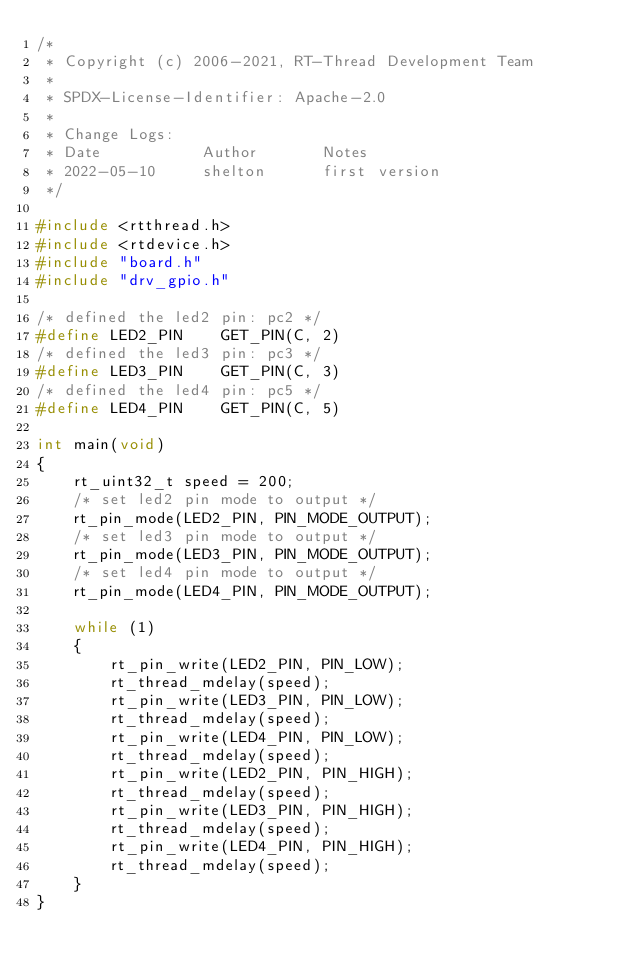<code> <loc_0><loc_0><loc_500><loc_500><_C_>/*
 * Copyright (c) 2006-2021, RT-Thread Development Team
 *
 * SPDX-License-Identifier: Apache-2.0
 *
 * Change Logs:
 * Date           Author       Notes
 * 2022-05-10     shelton      first version
 */

#include <rtthread.h>
#include <rtdevice.h>
#include "board.h"
#include "drv_gpio.h"

/* defined the led2 pin: pc2 */
#define LED2_PIN    GET_PIN(C, 2)
/* defined the led3 pin: pc3 */
#define LED3_PIN    GET_PIN(C, 3)
/* defined the led4 pin: pc5 */
#define LED4_PIN    GET_PIN(C, 5)

int main(void)
{
    rt_uint32_t speed = 200;
    /* set led2 pin mode to output */
    rt_pin_mode(LED2_PIN, PIN_MODE_OUTPUT);
    /* set led3 pin mode to output */
    rt_pin_mode(LED3_PIN, PIN_MODE_OUTPUT);
    /* set led4 pin mode to output */
    rt_pin_mode(LED4_PIN, PIN_MODE_OUTPUT);

    while (1)
    {
        rt_pin_write(LED2_PIN, PIN_LOW);
        rt_thread_mdelay(speed);
        rt_pin_write(LED3_PIN, PIN_LOW);
        rt_thread_mdelay(speed);
        rt_pin_write(LED4_PIN, PIN_LOW);
        rt_thread_mdelay(speed);
        rt_pin_write(LED2_PIN, PIN_HIGH);
        rt_thread_mdelay(speed);
        rt_pin_write(LED3_PIN, PIN_HIGH);
        rt_thread_mdelay(speed);
        rt_pin_write(LED4_PIN, PIN_HIGH);
        rt_thread_mdelay(speed);
    }
}
</code> 